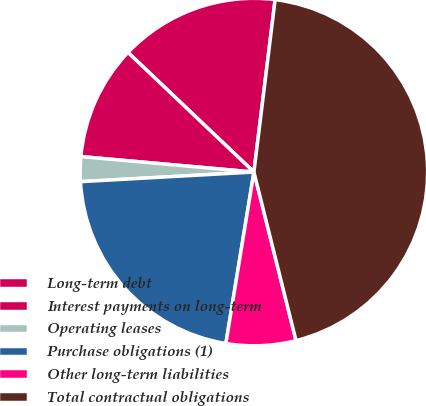Convert chart. <chart><loc_0><loc_0><loc_500><loc_500><pie_chart><fcel>Long-term debt<fcel>Interest payments on long-term<fcel>Operating leases<fcel>Purchase obligations (1)<fcel>Other long-term liabilities<fcel>Total contractual obligations<nl><fcel>14.86%<fcel>10.67%<fcel>2.3%<fcel>21.54%<fcel>6.48%<fcel>44.16%<nl></chart> 